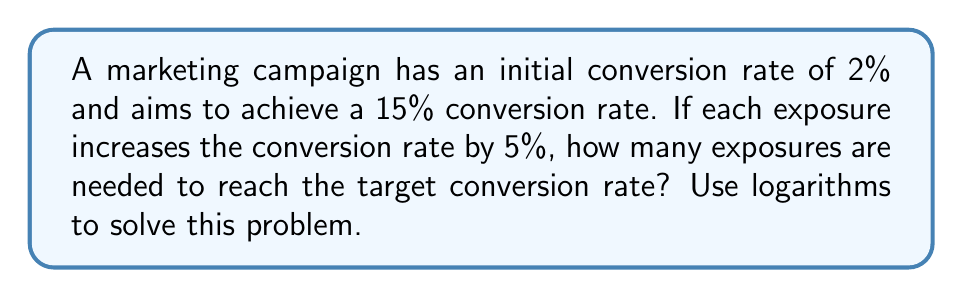Help me with this question. Let's approach this step-by-step:

1) Let $x$ be the number of exposures needed.

2) The conversion rate after $x$ exposures can be modeled as:
   $0.02 * (1.05)^x = 0.15$

3) Dividing both sides by 0.02:
   $(1.05)^x = 7.5$

4) Taking the natural logarithm of both sides:
   $x * \ln(1.05) = \ln(7.5)$

5) Solving for $x$:
   $x = \frac{\ln(7.5)}{\ln(1.05)}$

6) Using a calculator or computer:
   $x \approx 41.5897$

7) Since we can't have a fractional number of exposures, we round up to the nearest whole number.

Therefore, 42 exposures are needed to reach the target conversion rate.
Answer: 42 exposures 